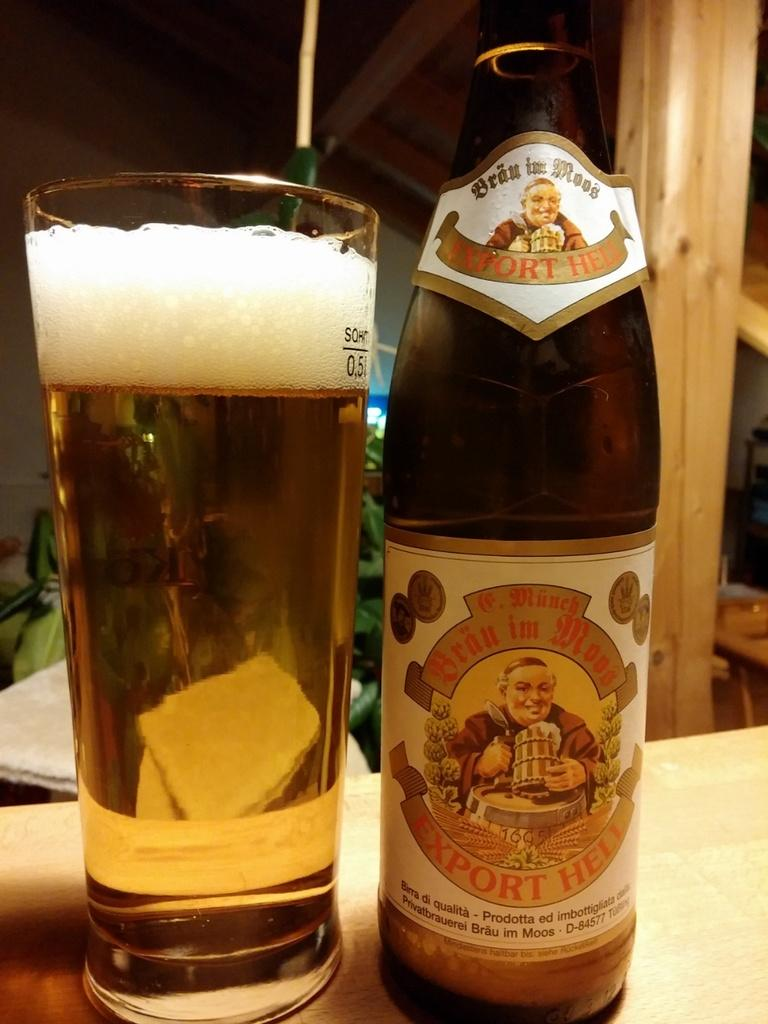Provide a one-sentence caption for the provided image. A bottle of beer has the identifying number D-84577 on the bottom part of its label. 